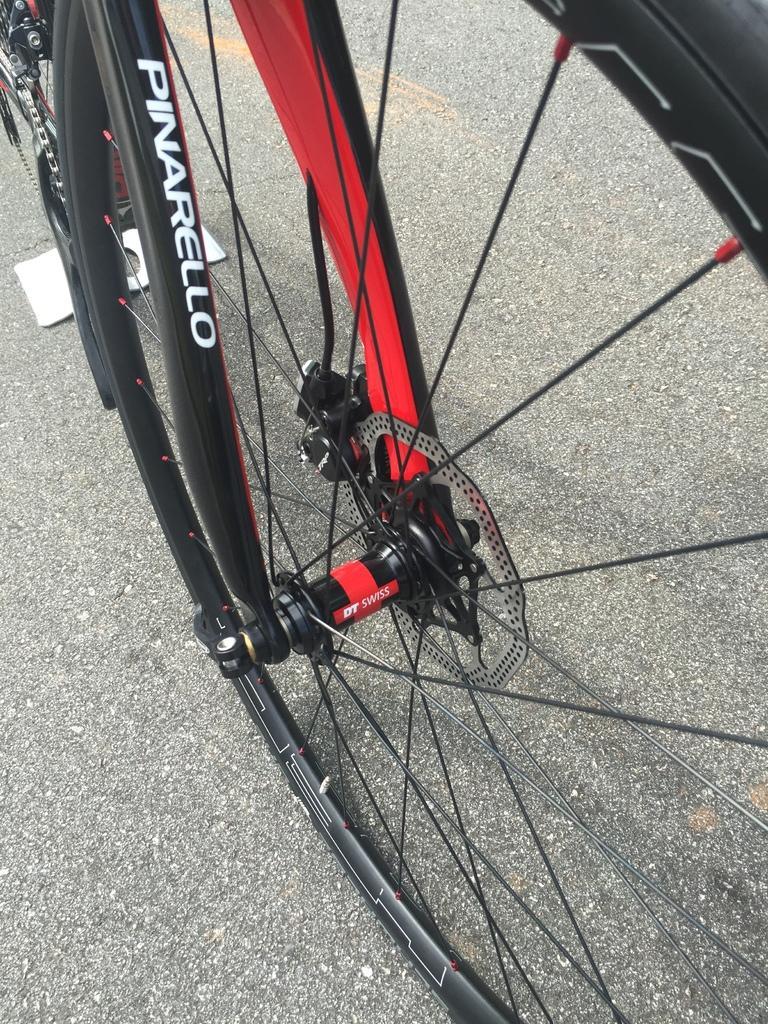Describe this image in one or two sentences. This is zoom-in picture of a wheel of a bicycle which is in black and red color. 